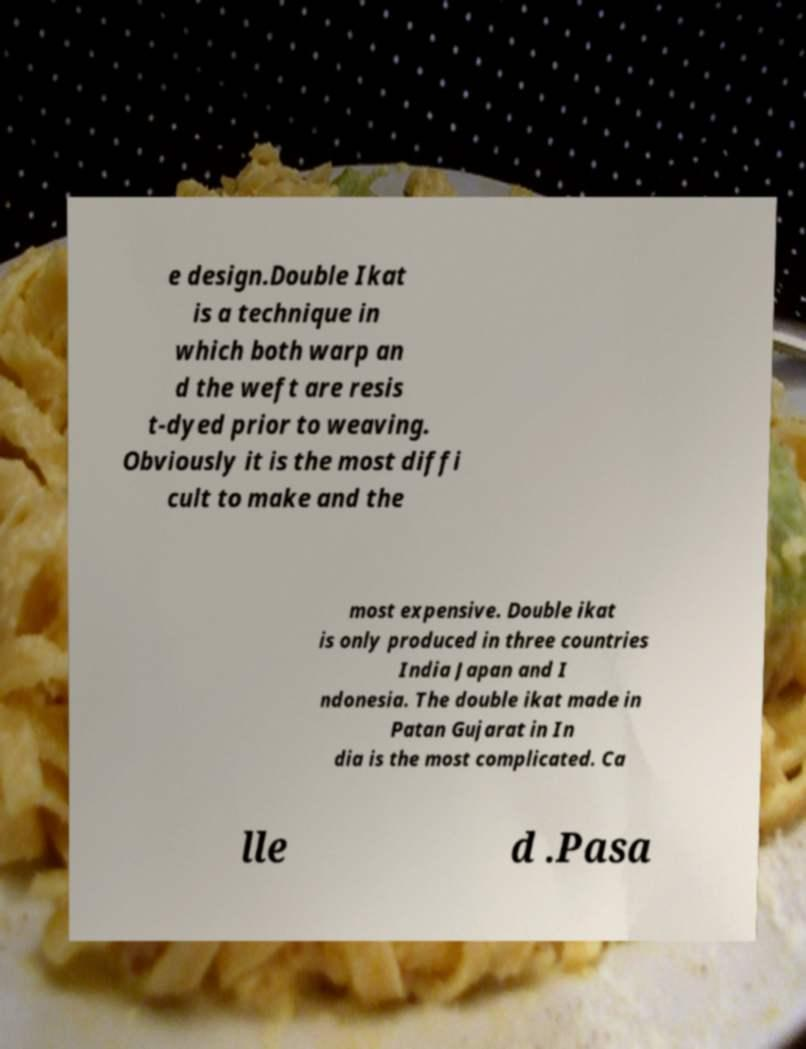Can you read and provide the text displayed in the image?This photo seems to have some interesting text. Can you extract and type it out for me? e design.Double Ikat is a technique in which both warp an d the weft are resis t-dyed prior to weaving. Obviously it is the most diffi cult to make and the most expensive. Double ikat is only produced in three countries India Japan and I ndonesia. The double ikat made in Patan Gujarat in In dia is the most complicated. Ca lle d .Pasa 